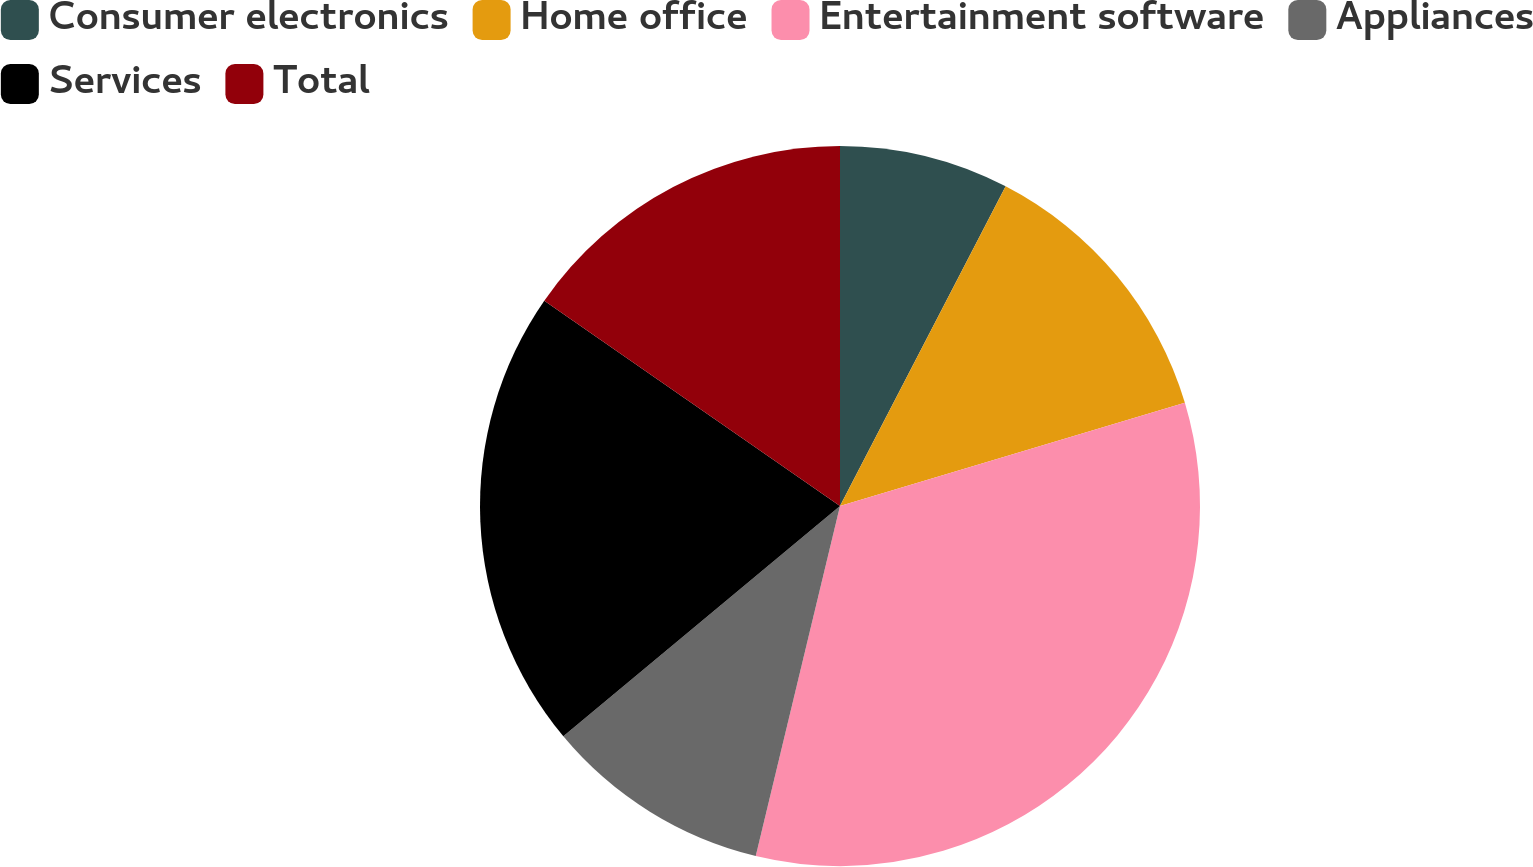<chart> <loc_0><loc_0><loc_500><loc_500><pie_chart><fcel>Consumer electronics<fcel>Home office<fcel>Entertainment software<fcel>Appliances<fcel>Services<fcel>Total<nl><fcel>7.61%<fcel>12.76%<fcel>33.39%<fcel>10.19%<fcel>20.71%<fcel>15.34%<nl></chart> 